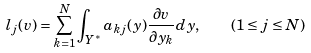<formula> <loc_0><loc_0><loc_500><loc_500>l _ { j } ( v ) = \sum _ { k = 1 } ^ { N } \int _ { Y ^ { * } } a _ { k j } ( y ) \frac { \partial v } { \partial y _ { k } } d y , \quad ( 1 \leq j \leq N )</formula> 